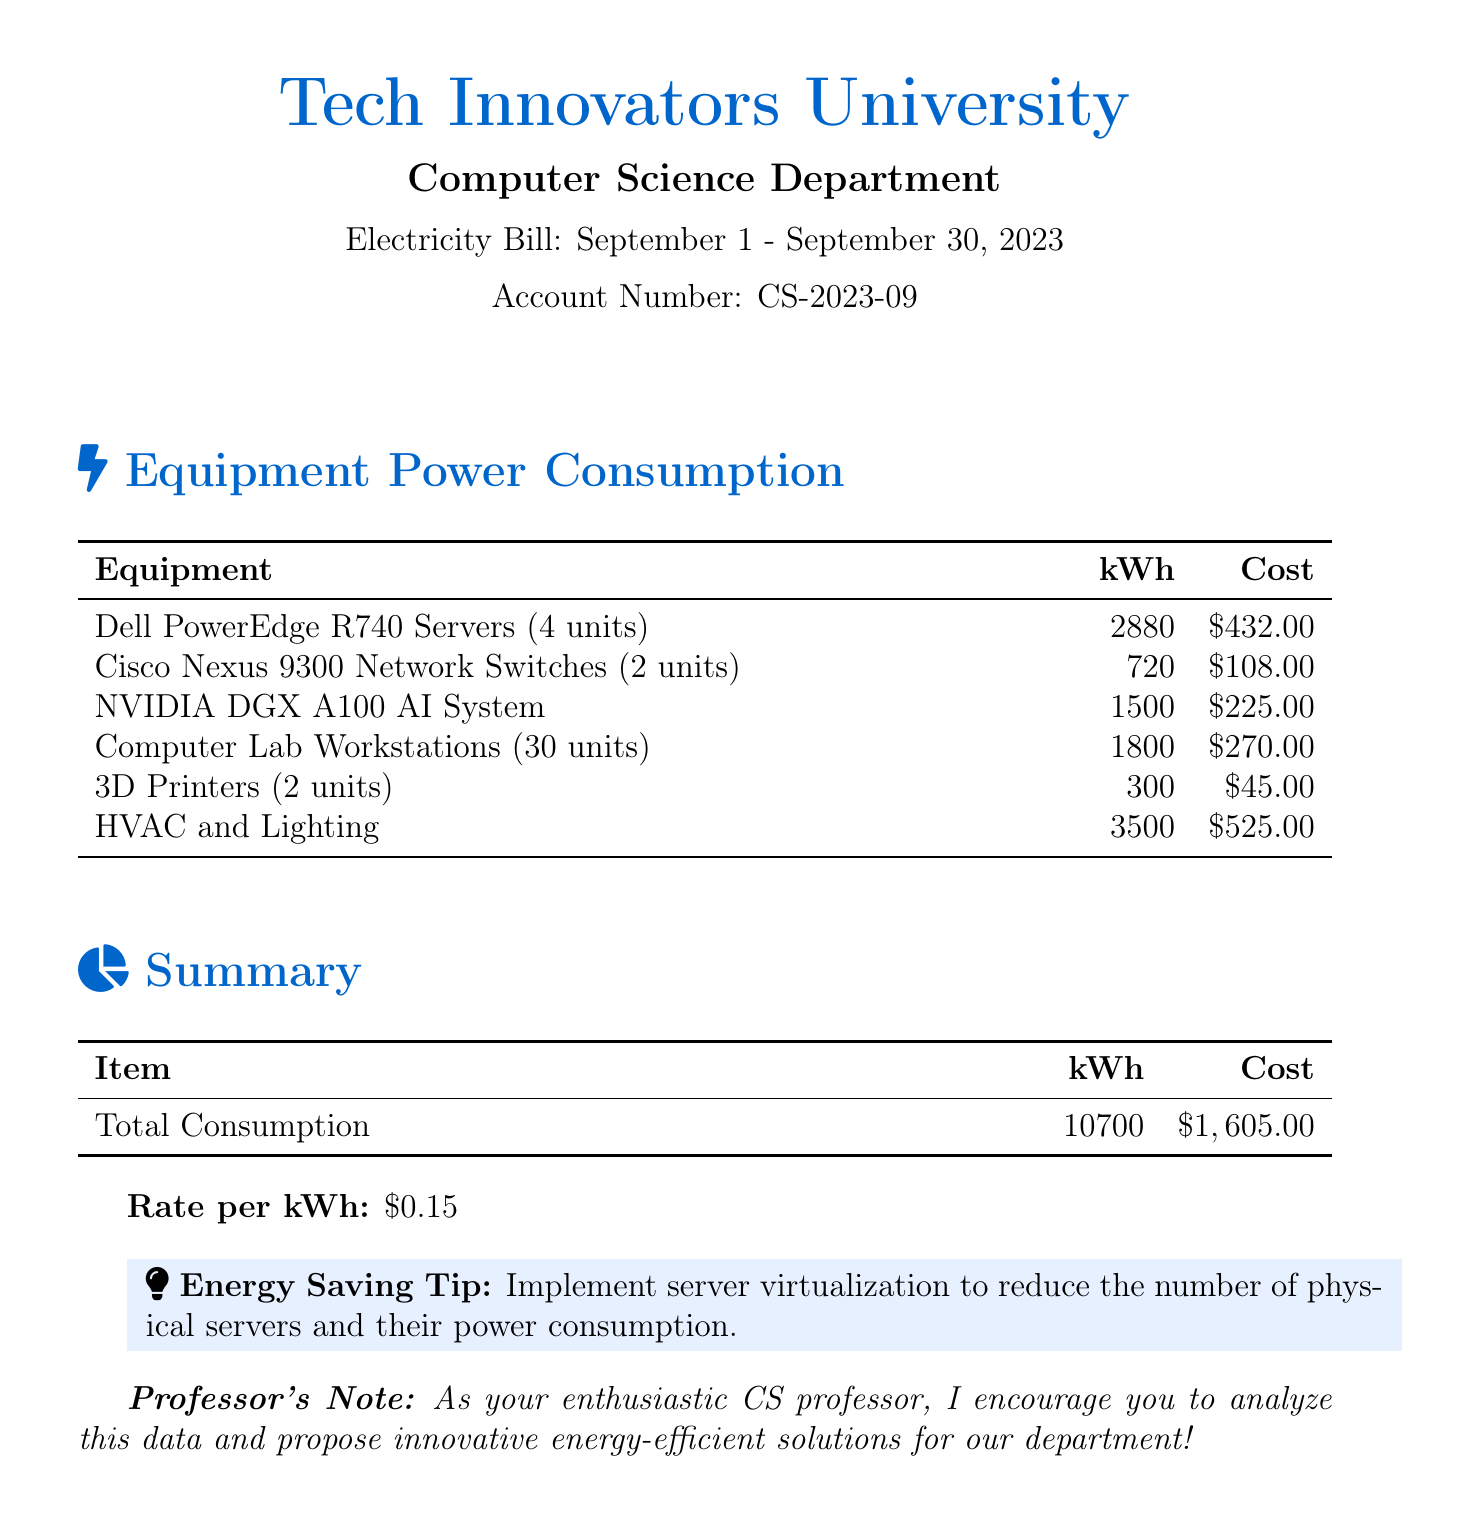What is the total power consumption? The total power consumption is listed under the summary section of the document, which states 10700 kWh.
Answer: 10700 kWh How much did the Dell PowerEdge R740 Servers cost? The cost of the Dell PowerEdge R740 Servers is detailed in the equipment power consumption table, which shows $432.00.
Answer: $432.00 What is the rate per kWh? The rate per kilowatt-hour (kWh) is specified at the bottom of the document, indicating $0.15.
Answer: $0.15 Which equipment consumed 3500 kWh? The document lists HVAC and Lighting as the equipment consuming 3500 kWh in the equipment table.
Answer: HVAC and Lighting How many workstations are in the computer lab? The number of computer lab workstations is presented in the equipment section, which indicates there are 30 units.
Answer: 30 units What is the total cost for the electricity consumed? The total cost for electricity consumption is given in the summary table as $1,605.00.
Answer: $1,605.00 How many units of the NVIDIA DGX A100 AI System are used? The document mentions one NVIDIA DGX A100 AI System in the equipment power consumption table.
Answer: One What is recommended to reduce power consumption? The energy saving tip suggests implementing server virtualization as a method to reduce power consumption.
Answer: Implement server virtualization What period does this electricity bill cover? The electricity bill specifies it covers the period from September 1 to September 30, 2023.
Answer: September 1 - September 30, 2023 